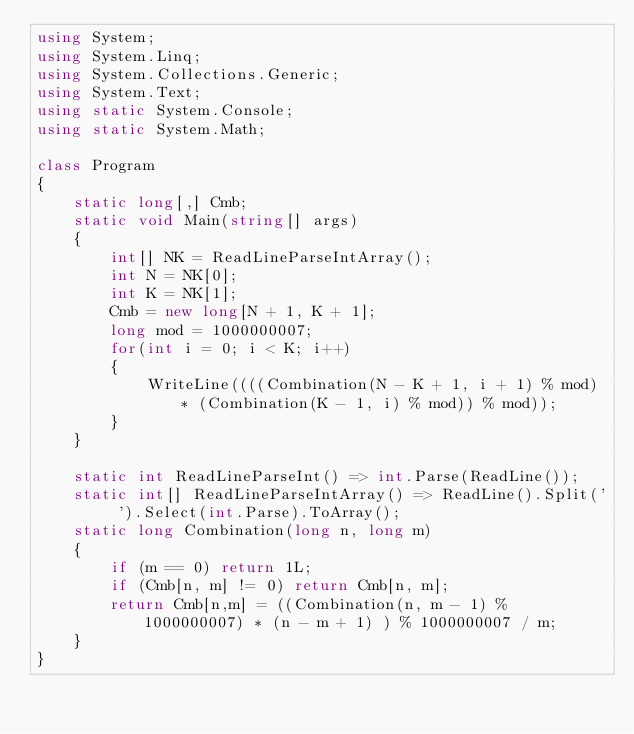<code> <loc_0><loc_0><loc_500><loc_500><_C#_>using System;
using System.Linq;
using System.Collections.Generic;
using System.Text;
using static System.Console;
using static System.Math;

class Program
{
    static long[,] Cmb;
    static void Main(string[] args)
    {
        int[] NK = ReadLineParseIntArray();
        int N = NK[0];
        int K = NK[1];
        Cmb = new long[N + 1, K + 1];
        long mod = 1000000007;
        for(int i = 0; i < K; i++)
        {
            WriteLine((((Combination(N - K + 1, i + 1) % mod) * (Combination(K - 1, i) % mod)) % mod));
        }
    }

    static int ReadLineParseInt() => int.Parse(ReadLine());
    static int[] ReadLineParseIntArray() => ReadLine().Split(' ').Select(int.Parse).ToArray();
    static long Combination(long n, long m)
    {
        if (m == 0) return 1L;
        if (Cmb[n, m] != 0) return Cmb[n, m];
        return Cmb[n,m] = ((Combination(n, m - 1) % 1000000007) * (n - m + 1) ) % 1000000007 / m;
    }
}</code> 